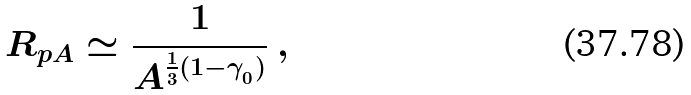Convert formula to latex. <formula><loc_0><loc_0><loc_500><loc_500>R _ { p A } \simeq \frac { 1 } { A ^ { \frac { 1 } { 3 } ( 1 - \gamma _ { _ { 0 } } ) } } \ ,</formula> 